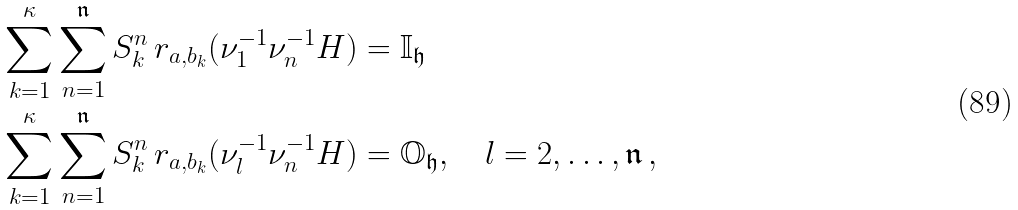<formula> <loc_0><loc_0><loc_500><loc_500>& \sum _ { k = 1 } ^ { \kappa } \sum _ { n = 1 } ^ { \mathfrak { n } } S _ { k } ^ { n } \, r _ { a , b _ { k } } ( \nu _ { 1 } ^ { - 1 } \nu _ { n } ^ { - 1 } H ) = \mathbb { I } _ { \mathfrak { h } } \\ & \sum _ { k = 1 } ^ { \kappa } \sum _ { n = 1 } ^ { \mathfrak { n } } S _ { k } ^ { n } \, r _ { a , b _ { k } } ( \nu _ { l } ^ { - 1 } \nu _ { n } ^ { - 1 } H ) = \mathbb { O } _ { \mathfrak { h } } , \quad l = 2 , \dots , \mathfrak { n } \, ,</formula> 